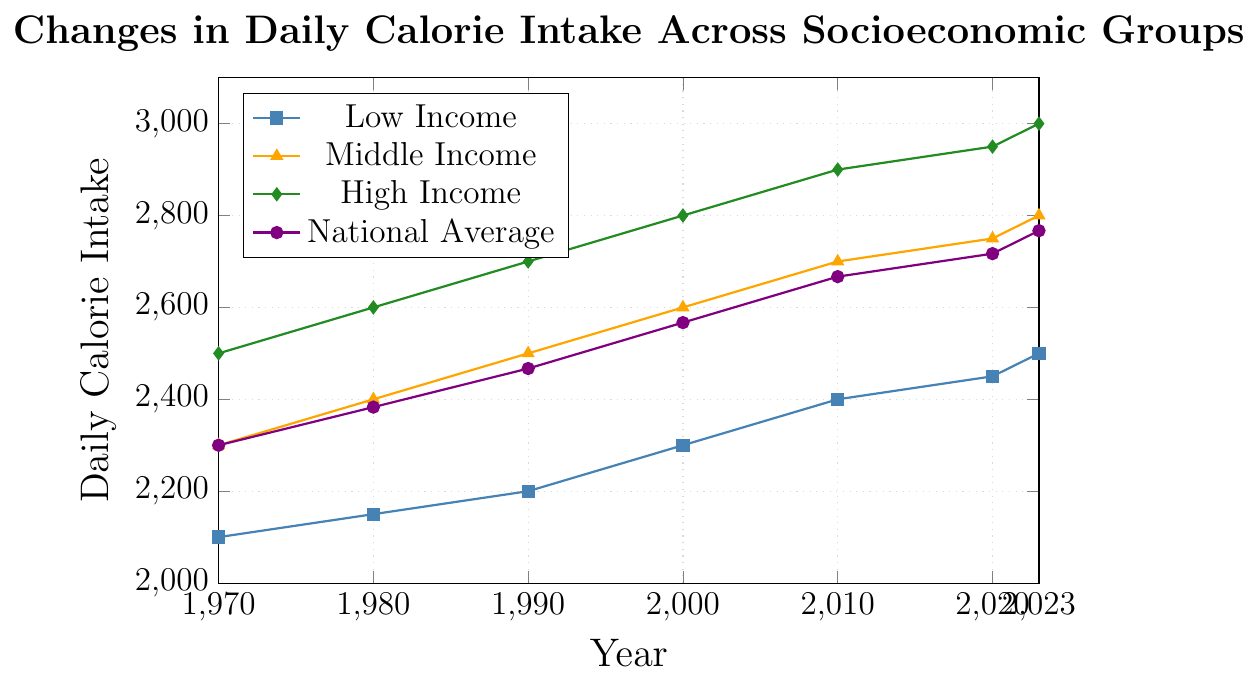Which socioeconomic group had the highest daily calorie intake in 1990? In the figure, the "High Income" group had a daily calorie intake of 2700 in 1990, which is higher than the calorie intakes of both the "Middle Income" and "Low Income" groups.
Answer: High Income How much has the daily calorie intake of the Low Income group increased from 1970 to 2023? The daily calorie intake for the Low Income group in 1970 was 2100, and in 2023 it is 2500. The increase can be calculated as 2500 - 2100 = 400.
Answer: 400 Which socioeconomic group has the smallest difference in calorie intake between 2010 and 2023? The "Low Income" group increased from 2400 to 2500 (difference of 100), the "Middle Income" group from 2700 to 2800 (difference of 100), and the "High Income" group from 2900 to 3000 (difference of 100). All groups show the same difference.
Answer: All groups Which year shows the smallest difference between the calorie intake of the High Income and Low Income groups? In 1970, the difference is 2500 - 2100 = 400. In 1980, the difference is 2600 - 2150 = 450. In 1990, the difference is 2700 - 2200 = 500. In 2000, the difference is 2800 - 2300 = 500. In 2010, the difference is 2900 - 2400 = 500. In 2020, the difference is 2950 - 2450 = 500. In 2023, the difference is 3000 - 2500 = 500. The smallest difference is in 1970.
Answer: 1970 What is the average daily calorie intake for the Middle Income group across all the given years? Adding up the values: 2300 + 2400 + 2500 + 2600 + 2700 + 2750 + 2800 = 18050. Then divide by the number of years, 18050 / 7 ≈ 2579.
Answer: 2579 In which year did the national average calorie intake first exceed 2500? Referencing the values from the figure, the national average first exceeded 2500 in the year 2000 with a value of 2567.
Answer: 2000 By how much did the national average calorie intake change from 2000 to 2023? The national average in 2000 was 2567, and in 2023 it is 2767. The change is 2767 - 2567 = 200.
Answer: 200 Which socioeconomic group experienced the highest rate of increase in daily calorie intake from 1970 to 2023? Calculation of the rates: Low Income increased from 2100 to 2500 (rate = (2500-2100)/2100 ≈ 0.1905). Middle Income increased from 2300 to 2800 (rate = (2800-2300)/2300 ≈ 0.2174). High Income increased from 2500 to 3000 (rate = (3000-2500)/2500 = 0.2). The Middle Income group experienced the highest rate of increase.
Answer: Middle Income 